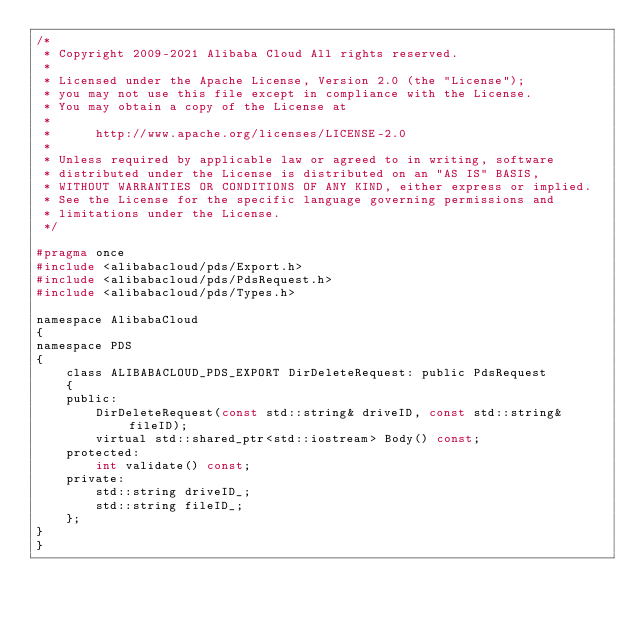<code> <loc_0><loc_0><loc_500><loc_500><_C_>/*
 * Copyright 2009-2021 Alibaba Cloud All rights reserved.
 *
 * Licensed under the Apache License, Version 2.0 (the "License");
 * you may not use this file except in compliance with the License.
 * You may obtain a copy of the License at
 *
 *      http://www.apache.org/licenses/LICENSE-2.0
 *
 * Unless required by applicable law or agreed to in writing, software
 * distributed under the License is distributed on an "AS IS" BASIS,
 * WITHOUT WARRANTIES OR CONDITIONS OF ANY KIND, either express or implied.
 * See the License for the specific language governing permissions and
 * limitations under the License.
 */

#pragma once
#include <alibabacloud/pds/Export.h>
#include <alibabacloud/pds/PdsRequest.h>
#include <alibabacloud/pds/Types.h>

namespace AlibabaCloud
{
namespace PDS
{
    class ALIBABACLOUD_PDS_EXPORT DirDeleteRequest: public PdsRequest
    {
    public:
        DirDeleteRequest(const std::string& driveID, const std::string& fileID);
        virtual std::shared_ptr<std::iostream> Body() const;
    protected:
        int validate() const;
    private:
        std::string driveID_;
        std::string fileID_;
    };
}
}
</code> 